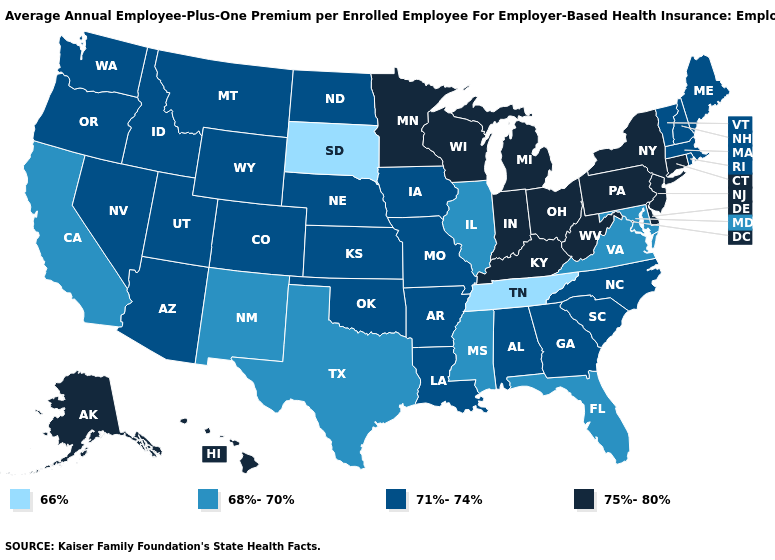What is the value of Maine?
Write a very short answer. 71%-74%. Among the states that border Missouri , does Kansas have the lowest value?
Keep it brief. No. Does New Mexico have the same value as Oregon?
Keep it brief. No. Name the states that have a value in the range 71%-74%?
Be succinct. Alabama, Arizona, Arkansas, Colorado, Georgia, Idaho, Iowa, Kansas, Louisiana, Maine, Massachusetts, Missouri, Montana, Nebraska, Nevada, New Hampshire, North Carolina, North Dakota, Oklahoma, Oregon, Rhode Island, South Carolina, Utah, Vermont, Washington, Wyoming. What is the value of Virginia?
Give a very brief answer. 68%-70%. Name the states that have a value in the range 66%?
Keep it brief. South Dakota, Tennessee. Which states hav the highest value in the Northeast?
Concise answer only. Connecticut, New Jersey, New York, Pennsylvania. What is the value of Colorado?
Quick response, please. 71%-74%. Does the map have missing data?
Short answer required. No. Name the states that have a value in the range 66%?
Short answer required. South Dakota, Tennessee. What is the highest value in the Northeast ?
Be succinct. 75%-80%. What is the value of California?
Short answer required. 68%-70%. What is the lowest value in states that border Utah?
Keep it brief. 68%-70%. What is the lowest value in states that border Illinois?
Write a very short answer. 71%-74%. 